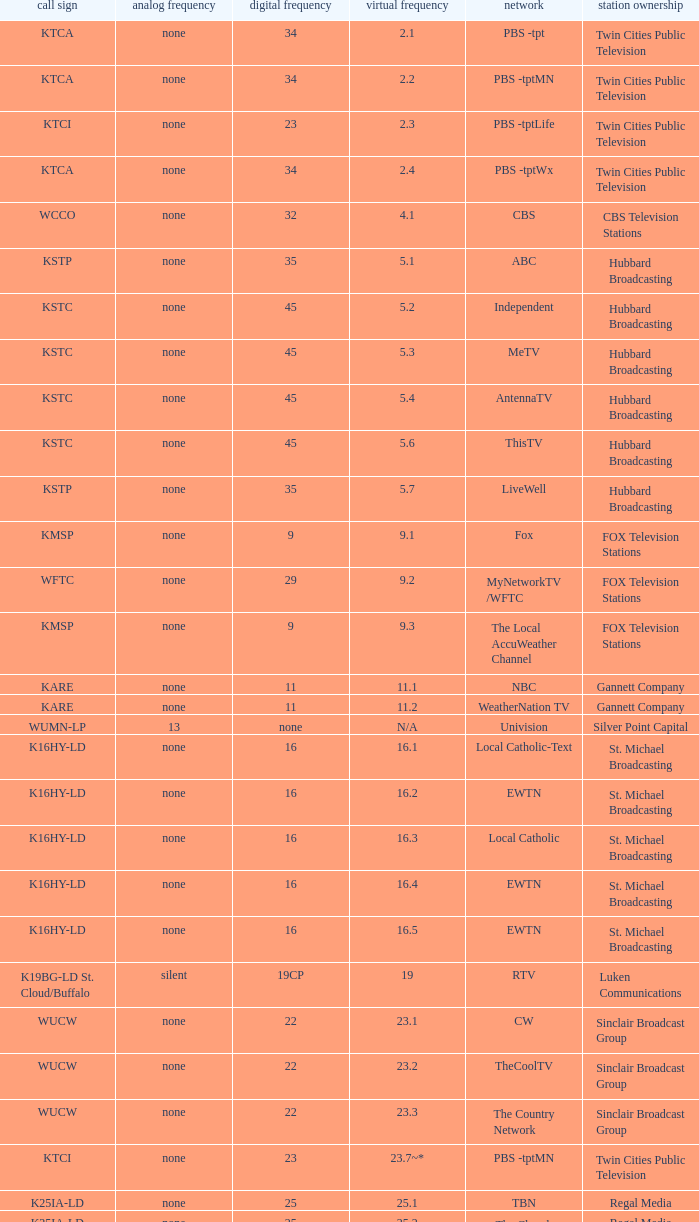Station Ownership of eicb tv, and a Call sign of ktcj-ld is what virtual network? 50.1. 